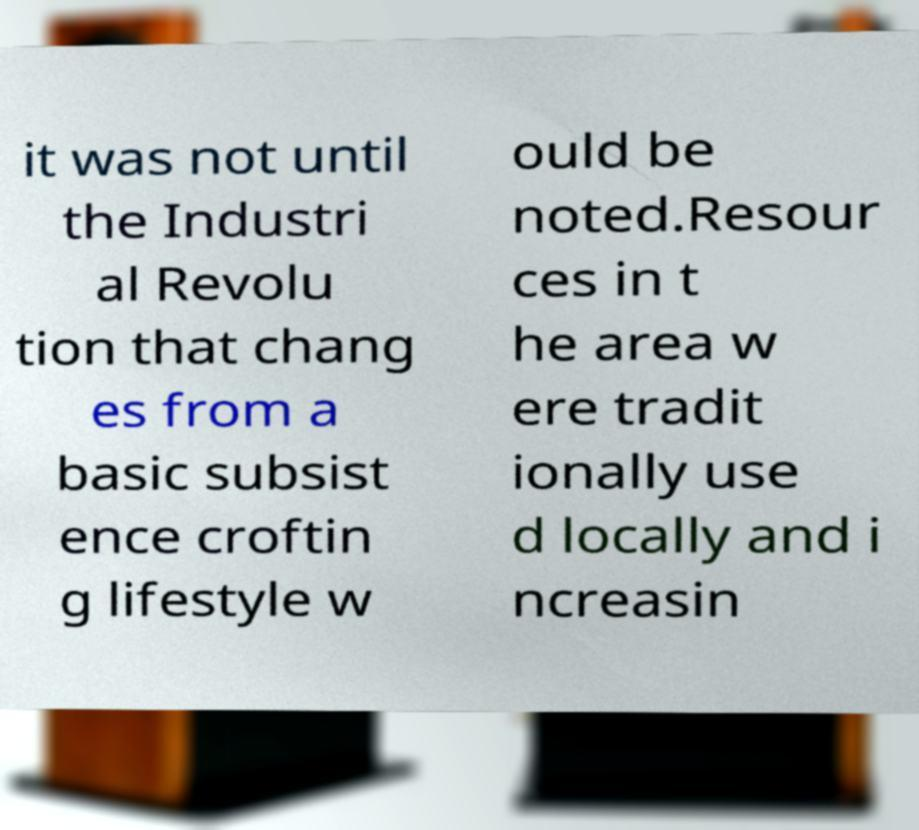There's text embedded in this image that I need extracted. Can you transcribe it verbatim? it was not until the Industri al Revolu tion that chang es from a basic subsist ence croftin g lifestyle w ould be noted.Resour ces in t he area w ere tradit ionally use d locally and i ncreasin 